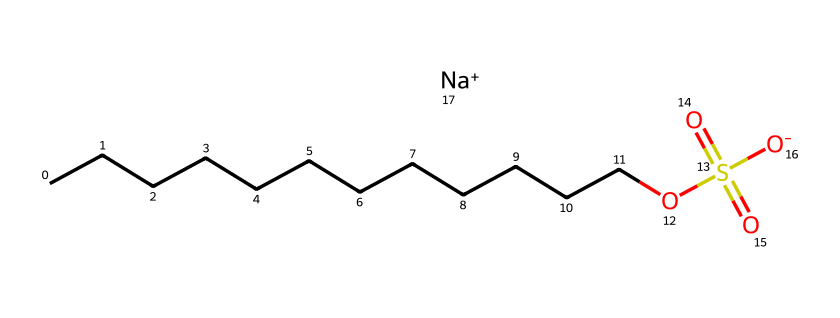What is the chemical name represented by this SMILES? The SMILES representation indicates a molecule with a long hydrocarbon chain (CCCCCCCCCCCC) and a sulfate group (OS(=O)(=O)[O-]). This corresponds to sodium lauryl sulfate, commonly found in detergents.
Answer: sodium lauryl sulfate How many carbon atoms are in sodium lauryl sulfate? The carbon chain (CCCCCCCCCCCC) consists of 12 carbon atoms.
Answer: 12 What functional group is present in this chemical? The chemical contains a sulfate group (OS(=O)(=O)[O-]), which is characteristic of surfactants like sodium lauryl sulfate.
Answer: sulfate What ion does this detergent form in solution? The chemical ends with [Na+], indicating that it dissociates to form a sodium ion in solution.
Answer: sodium ion How does the long carbon chain affect the detergent's properties? The long hydrocarbon chain contributes to the hydrophobic nature of sodium lauryl sulfate, allowing it to interact with oils and grease, making it effective as a detergent.
Answer: hydrophobic Is sodium lauryl sulfate anionic or cationic? The presence of the negatively charged sulfate group (OS(=O)(=O)[O-]) indicates that sodium lauryl sulfate is anionic.
Answer: anionic 